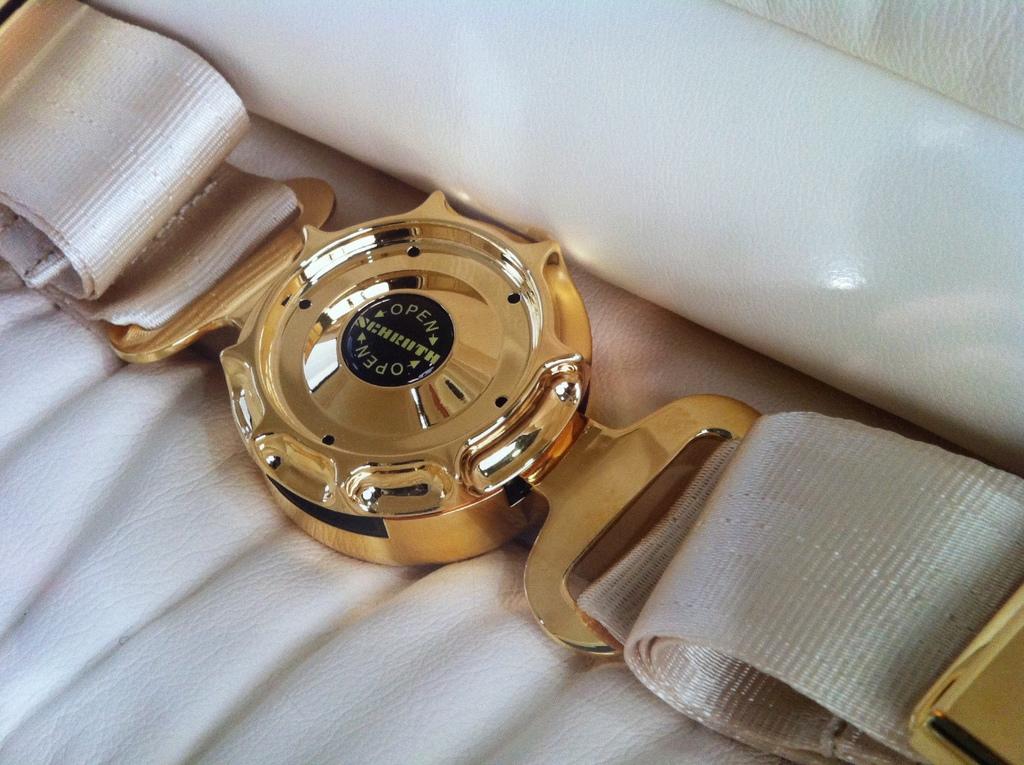What word is written on the back of the watch?
Keep it short and to the point. Open. What word is repeated on the buckle?
Your answer should be compact. Open. 